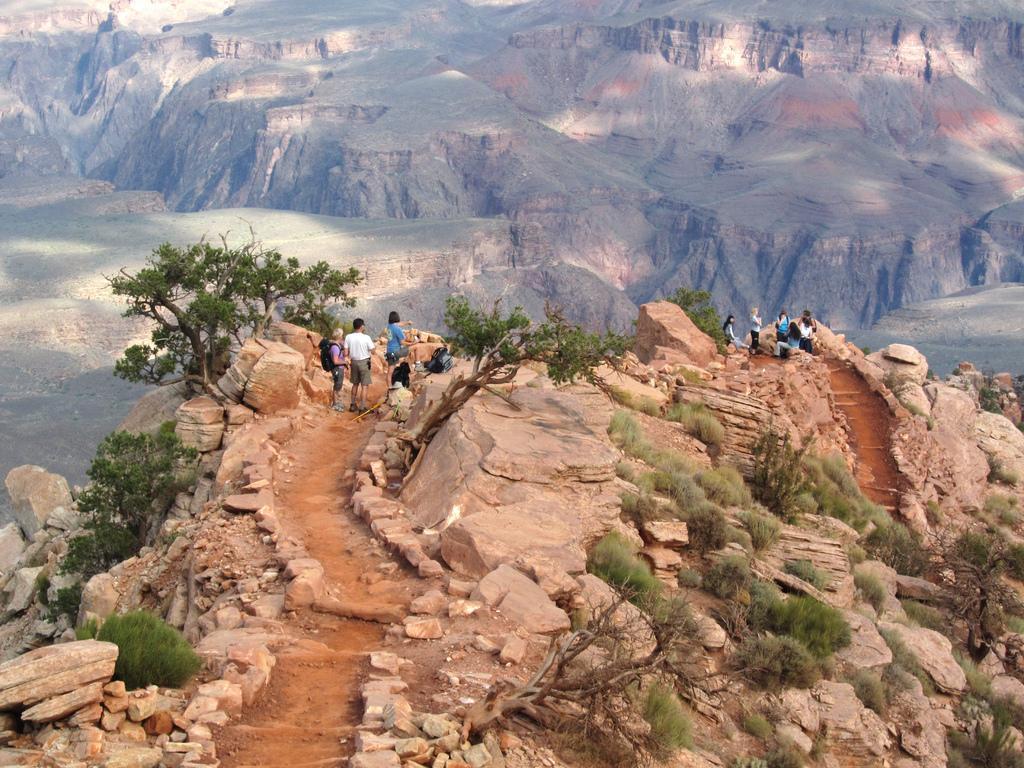How would you summarize this image in a sentence or two? In the picture we can see some rock hill with a path and besides, we can see some plants and some people are standing and some are sitting on the rocks and in the background we can see rock hills. 